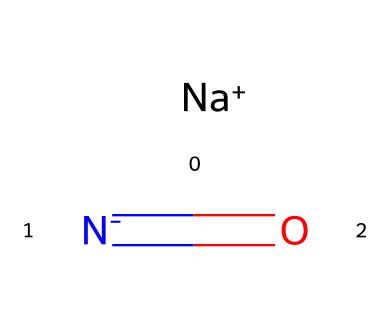What is the main element in sodium nitrite? The chemical contains sodium (Na) as a cation, which is the primary element in its composition, indicated by the presence of [Na+].
Answer: sodium How many nitrogen atoms are in sodium nitrite? In the chemical structure, there is one nitrogen atom present, which can be identified in the formula as part of the nitrite group (N=O).
Answer: one What type of bonding exists between the sodium and nitrite components? The interaction between the sodium ion and the nitrite ion involves ionic bonding, where sodium acts as a cation and the nitrite ion carries a negative charge.
Answer: ionic What is the total number of atoms in sodium nitrite? Sodium nitrite is made up of one sodium atom, one nitrogen atom, and two oxygen atoms, totaling four atoms when counted together.
Answer: four What type of chemical is sodium nitrite classified as? Sodium nitrite is classified as a preservative due to its role in inhibiting bacterial growth and preserving the color of cured meats, as indicated by its usage.
Answer: preservative What is the oxidation state of nitrogen in sodium nitrite? The nitrogen atom in sodium nitrite has a formal oxidation state of +3, which can be reasoned from its connection to oxygen in the nitrite structure.
Answer: +3 What is the primary function of sodium nitrite in food preservation? Sodium nitrite primarily acts to prevent the growth of harmful bacteria such as Clostridium botulinum in cured meats, which can be deduced from its role as a preservative.
Answer: prevent bacteria 